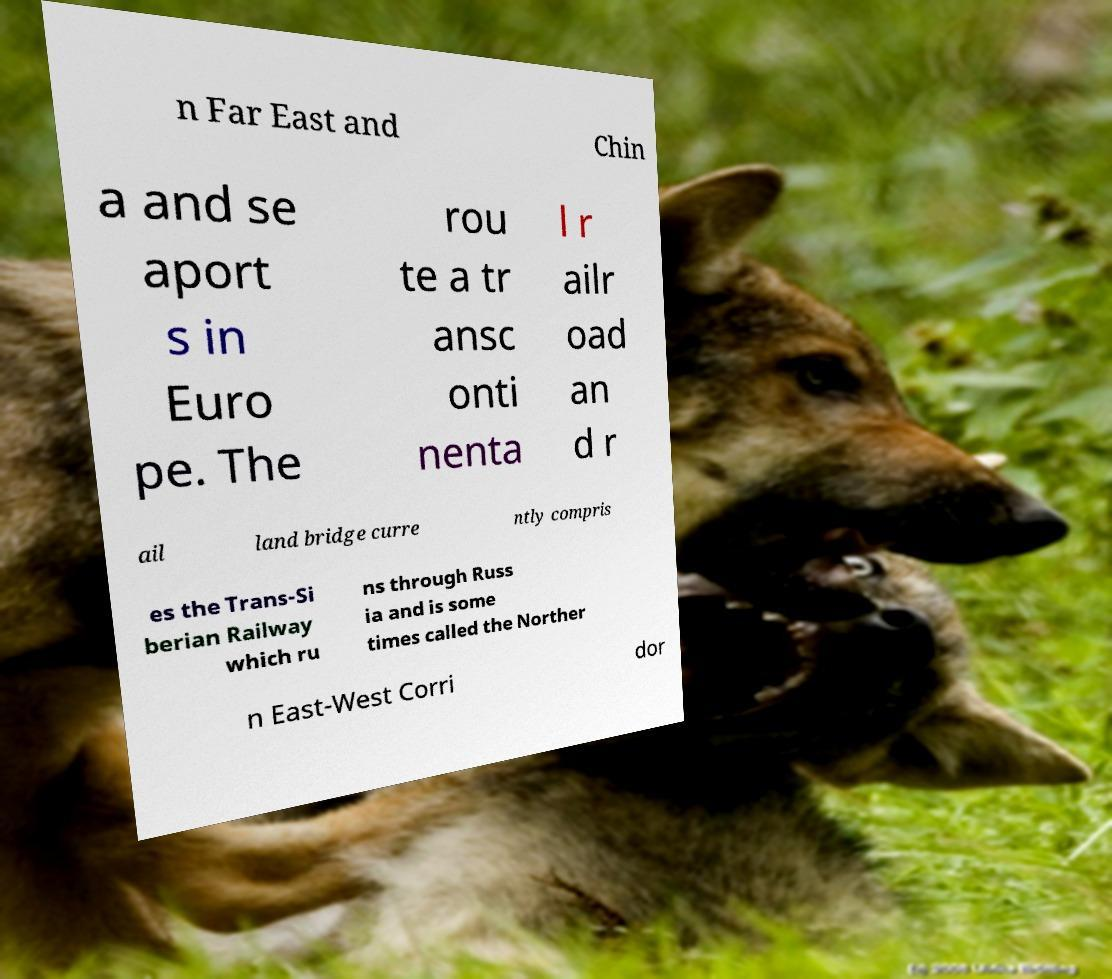For documentation purposes, I need the text within this image transcribed. Could you provide that? n Far East and Chin a and se aport s in Euro pe. The rou te a tr ansc onti nenta l r ailr oad an d r ail land bridge curre ntly compris es the Trans-Si berian Railway which ru ns through Russ ia and is some times called the Norther n East-West Corri dor 